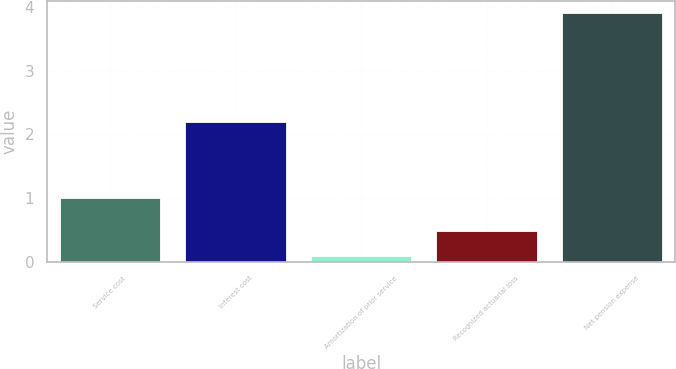Convert chart. <chart><loc_0><loc_0><loc_500><loc_500><bar_chart><fcel>Service cost<fcel>Interest cost<fcel>Amortization of prior service<fcel>Recognized actuarial loss<fcel>Net pension expense<nl><fcel>1<fcel>2.2<fcel>0.1<fcel>0.48<fcel>3.9<nl></chart> 